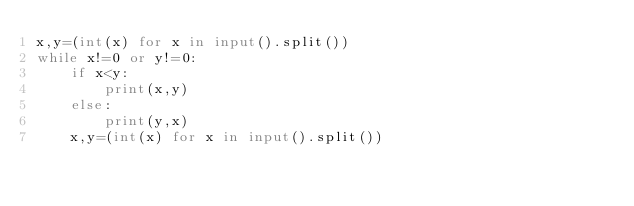Convert code to text. <code><loc_0><loc_0><loc_500><loc_500><_Python_>x,y=(int(x) for x in input().split())
while x!=0 or y!=0:
    if x<y:
        print(x,y)
    else:
        print(y,x)
    x,y=(int(x) for x in input().split())
</code> 